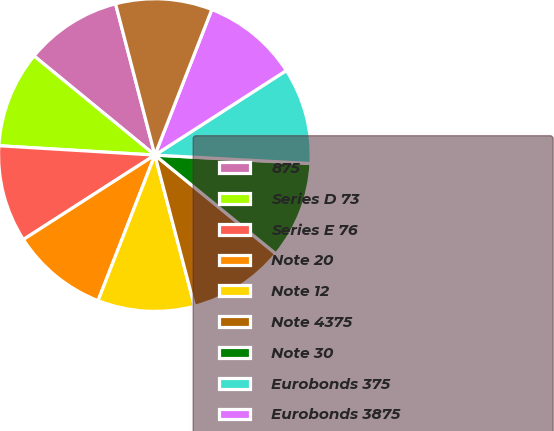<chart> <loc_0><loc_0><loc_500><loc_500><pie_chart><fcel>875<fcel>Series D 73<fcel>Series E 76<fcel>Note 20<fcel>Note 12<fcel>Note 4375<fcel>Note 30<fcel>Eurobonds 375<fcel>Eurobonds 3875<fcel>RMB Syndicated Credit Facility<nl><fcel>10.02%<fcel>9.98%<fcel>10.04%<fcel>9.99%<fcel>10.01%<fcel>10.02%<fcel>10.03%<fcel>9.96%<fcel>9.97%<fcel>9.98%<nl></chart> 